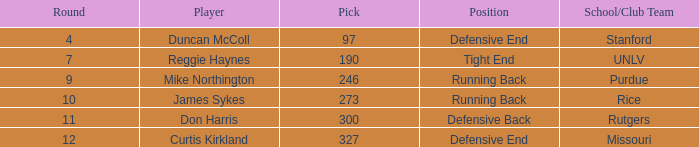What is the total number of rounds that had draft pick 97, duncan mccoll? 0.0. 